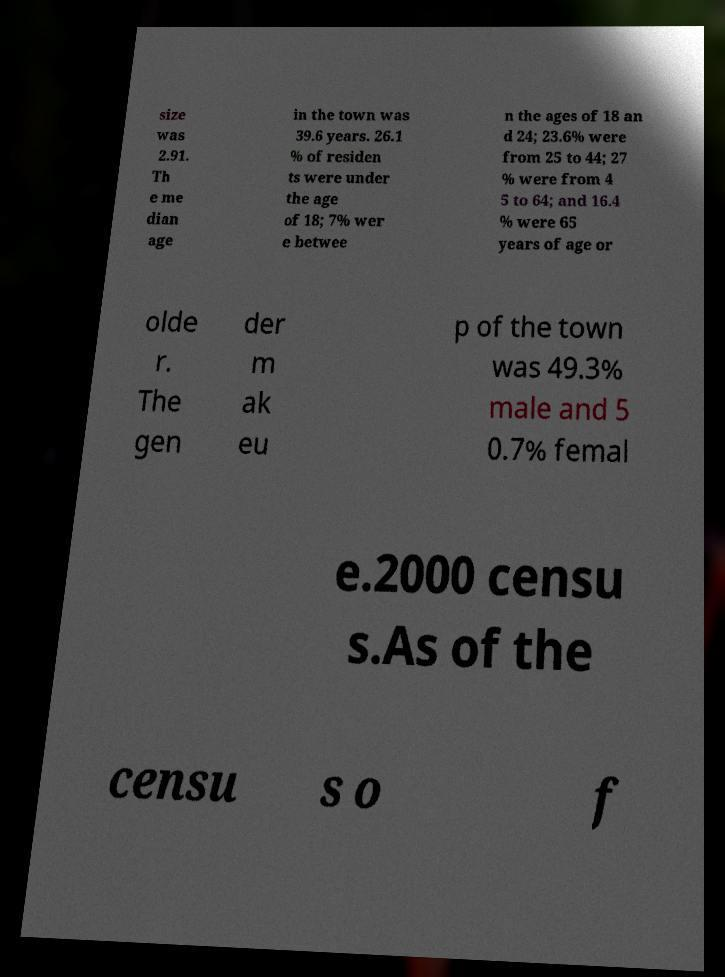Could you assist in decoding the text presented in this image and type it out clearly? size was 2.91. Th e me dian age in the town was 39.6 years. 26.1 % of residen ts were under the age of 18; 7% wer e betwee n the ages of 18 an d 24; 23.6% were from 25 to 44; 27 % were from 4 5 to 64; and 16.4 % were 65 years of age or olde r. The gen der m ak eu p of the town was 49.3% male and 5 0.7% femal e.2000 censu s.As of the censu s o f 